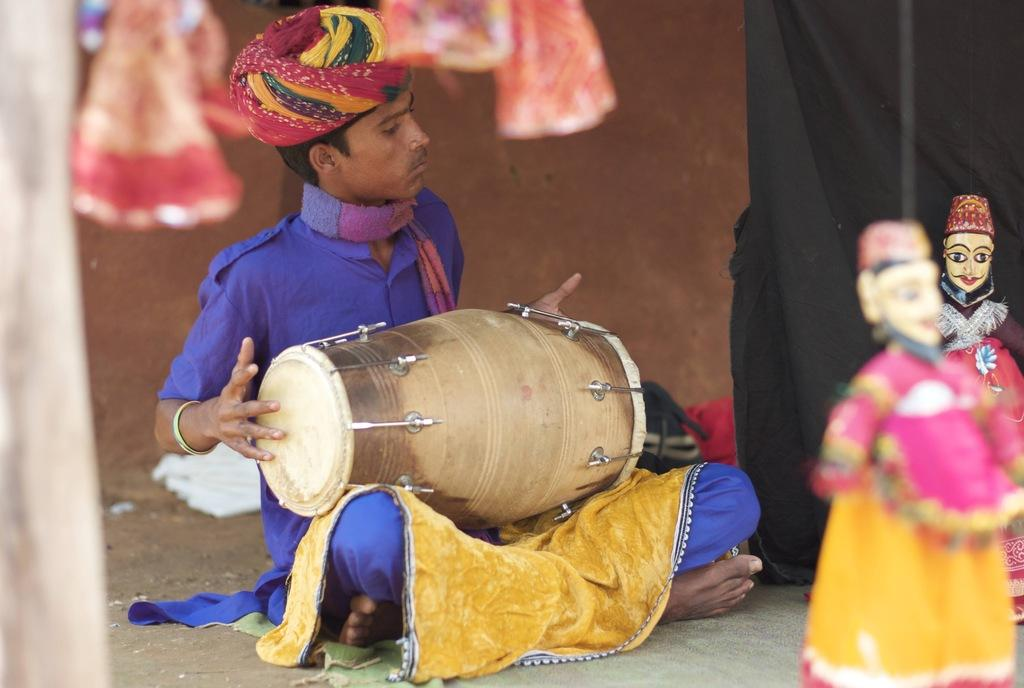What is the man in the image doing? The man is playing a drum in the image. What else can be seen in the image besides the man playing the drum? There are two toys in the image. What type of wire is being used to cut the rail in the image? There is no wire or rail present in the image; it only features a man playing a drum and two toys. 